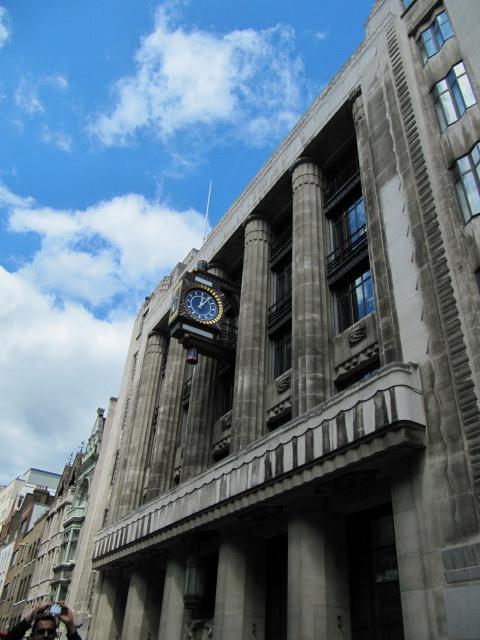What is the blue sign with a 2 on it for?
Keep it brief. Clock. Is there a clock in this picture?
Be succinct. Yes. What is the building made of?
Quick response, please. Stone. What city is Downing Street SW1?
Be succinct. London. How many windows are visible?
Concise answer only. 5. Is this an apartment building?
Write a very short answer. No. Where is the clock located?
Keep it brief. On building. What number is the clock's second hand on?
Be succinct. 1. Is the sky clear?
Give a very brief answer. No. How many walls are there?
Keep it brief. 1. What is the architectural style of this building?
Quick response, please. Roman. Is this a church tower?
Keep it brief. No. Do the rooftops have points?
Concise answer only. No. Where is the clock?
Give a very brief answer. On building. 